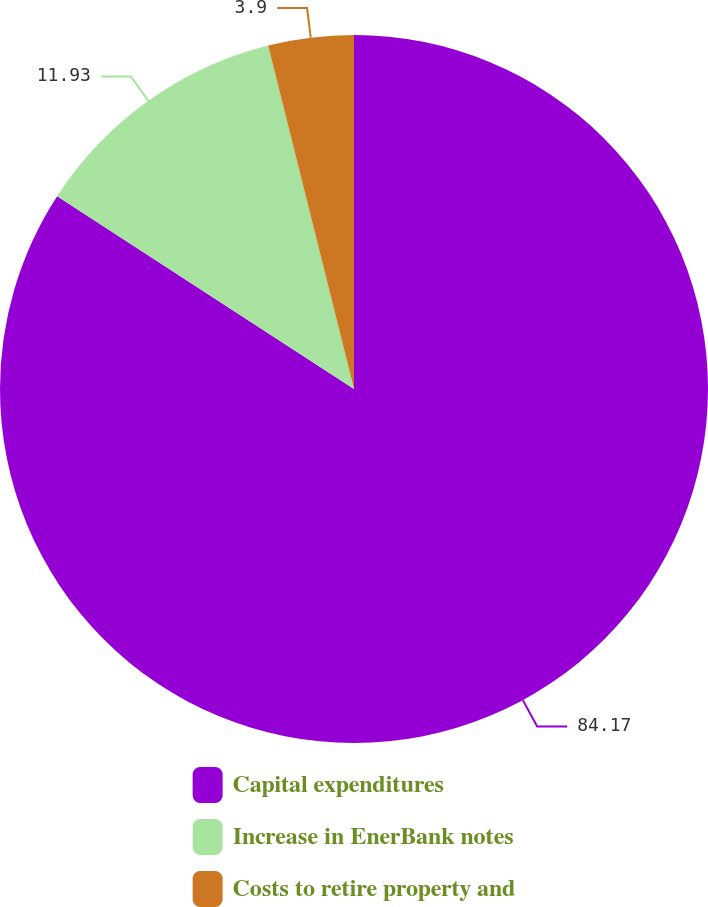<chart> <loc_0><loc_0><loc_500><loc_500><pie_chart><fcel>Capital expenditures<fcel>Increase in EnerBank notes<fcel>Costs to retire property and<nl><fcel>84.17%<fcel>11.93%<fcel>3.9%<nl></chart> 